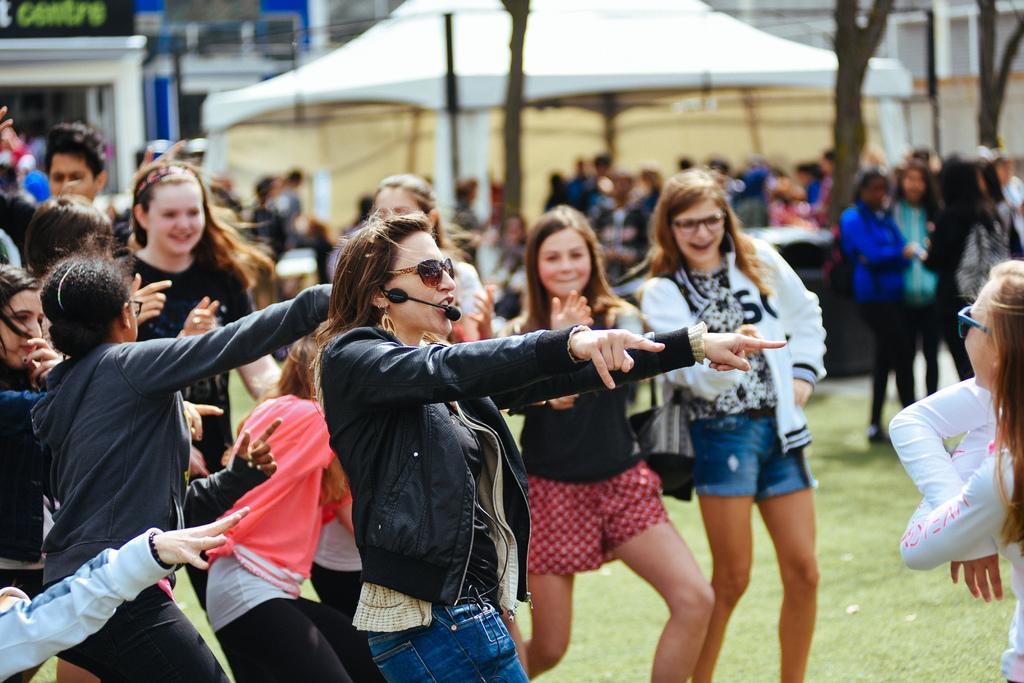How many people are in the image? There are many people in the image. What are the people doing in the image? The people appear to be dancing. What can be seen in the background of the image? There is a tent in the background of the image. What type of vegetation is present in the image? Trees are present in front of the text in the image. Can you find the receipt for the event in the image? There is no receipt present in the image. Is there a donkey participating in the dance in the image? There is no donkey present in the image. 